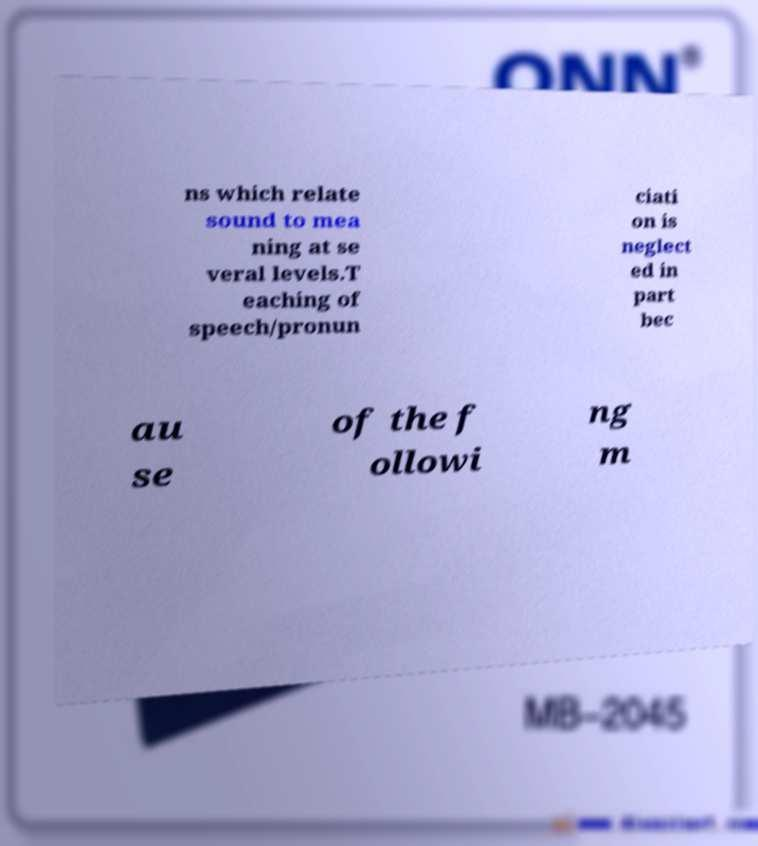Please read and relay the text visible in this image. What does it say? ns which relate sound to mea ning at se veral levels.T eaching of speech/pronun ciati on is neglect ed in part bec au se of the f ollowi ng m 